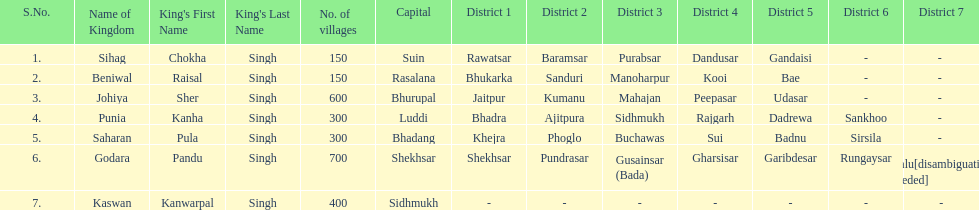Which kingdom has the most villages? Godara. 